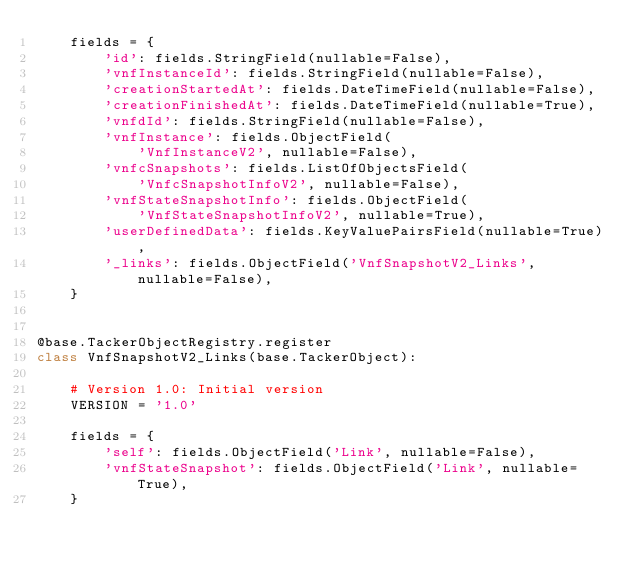Convert code to text. <code><loc_0><loc_0><loc_500><loc_500><_Python_>    fields = {
        'id': fields.StringField(nullable=False),
        'vnfInstanceId': fields.StringField(nullable=False),
        'creationStartedAt': fields.DateTimeField(nullable=False),
        'creationFinishedAt': fields.DateTimeField(nullable=True),
        'vnfdId': fields.StringField(nullable=False),
        'vnfInstance': fields.ObjectField(
            'VnfInstanceV2', nullable=False),
        'vnfcSnapshots': fields.ListOfObjectsField(
            'VnfcSnapshotInfoV2', nullable=False),
        'vnfStateSnapshotInfo': fields.ObjectField(
            'VnfStateSnapshotInfoV2', nullable=True),
        'userDefinedData': fields.KeyValuePairsField(nullable=True),
        '_links': fields.ObjectField('VnfSnapshotV2_Links', nullable=False),
    }


@base.TackerObjectRegistry.register
class VnfSnapshotV2_Links(base.TackerObject):

    # Version 1.0: Initial version
    VERSION = '1.0'

    fields = {
        'self': fields.ObjectField('Link', nullable=False),
        'vnfStateSnapshot': fields.ObjectField('Link', nullable=True),
    }
</code> 